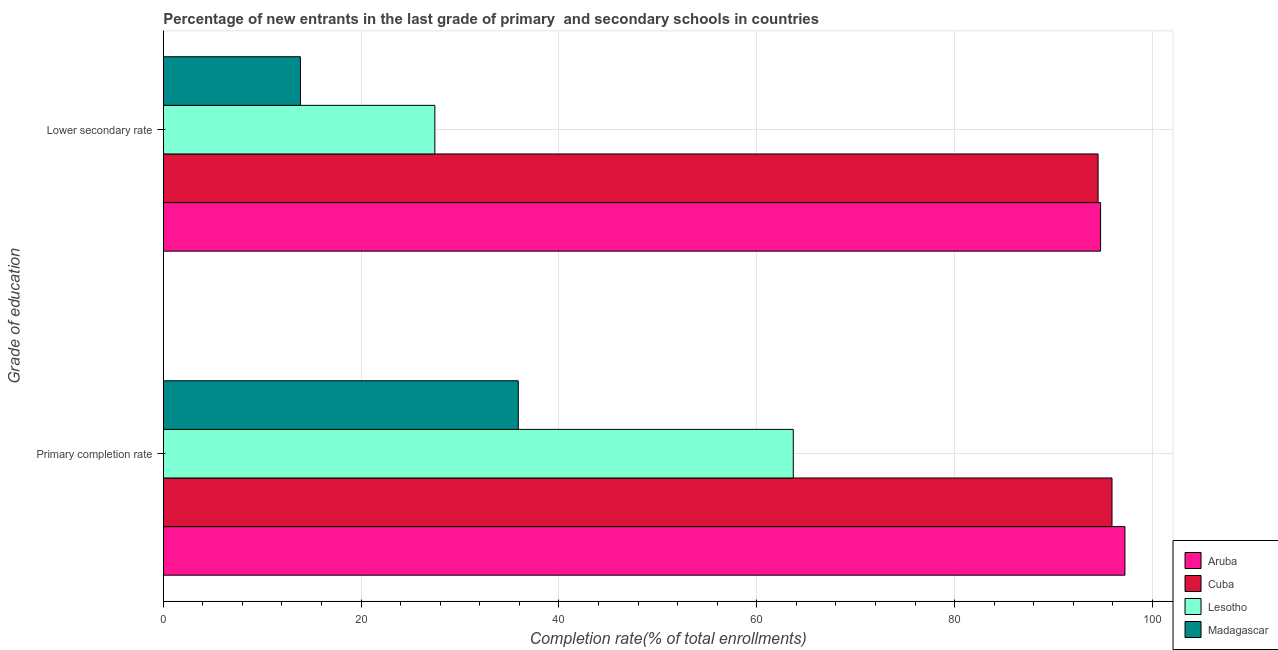How many groups of bars are there?
Offer a very short reply. 2. Are the number of bars per tick equal to the number of legend labels?
Give a very brief answer. Yes. Are the number of bars on each tick of the Y-axis equal?
Your response must be concise. Yes. What is the label of the 1st group of bars from the top?
Provide a short and direct response. Lower secondary rate. What is the completion rate in secondary schools in Lesotho?
Your response must be concise. 27.46. Across all countries, what is the maximum completion rate in secondary schools?
Offer a very short reply. 94.75. Across all countries, what is the minimum completion rate in primary schools?
Offer a very short reply. 35.89. In which country was the completion rate in primary schools maximum?
Your answer should be very brief. Aruba. In which country was the completion rate in secondary schools minimum?
Ensure brevity in your answer.  Madagascar. What is the total completion rate in secondary schools in the graph?
Offer a very short reply. 230.57. What is the difference between the completion rate in primary schools in Cuba and that in Aruba?
Ensure brevity in your answer.  -1.31. What is the difference between the completion rate in primary schools in Lesotho and the completion rate in secondary schools in Cuba?
Your answer should be very brief. -30.81. What is the average completion rate in primary schools per country?
Your answer should be very brief. 73.17. What is the difference between the completion rate in primary schools and completion rate in secondary schools in Aruba?
Your response must be concise. 2.46. In how many countries, is the completion rate in secondary schools greater than 48 %?
Keep it short and to the point. 2. What is the ratio of the completion rate in primary schools in Aruba to that in Lesotho?
Your response must be concise. 1.53. What does the 3rd bar from the top in Lower secondary rate represents?
Offer a terse response. Cuba. What does the 4th bar from the bottom in Lower secondary rate represents?
Provide a short and direct response. Madagascar. What is the difference between two consecutive major ticks on the X-axis?
Keep it short and to the point. 20. Are the values on the major ticks of X-axis written in scientific E-notation?
Your response must be concise. No. Does the graph contain any zero values?
Ensure brevity in your answer.  No. What is the title of the graph?
Make the answer very short. Percentage of new entrants in the last grade of primary  and secondary schools in countries. What is the label or title of the X-axis?
Make the answer very short. Completion rate(% of total enrollments). What is the label or title of the Y-axis?
Make the answer very short. Grade of education. What is the Completion rate(% of total enrollments) in Aruba in Primary completion rate?
Your answer should be very brief. 97.22. What is the Completion rate(% of total enrollments) in Cuba in Primary completion rate?
Your answer should be very brief. 95.91. What is the Completion rate(% of total enrollments) in Lesotho in Primary completion rate?
Provide a succinct answer. 63.69. What is the Completion rate(% of total enrollments) in Madagascar in Primary completion rate?
Give a very brief answer. 35.89. What is the Completion rate(% of total enrollments) in Aruba in Lower secondary rate?
Make the answer very short. 94.75. What is the Completion rate(% of total enrollments) in Cuba in Lower secondary rate?
Your answer should be compact. 94.5. What is the Completion rate(% of total enrollments) of Lesotho in Lower secondary rate?
Make the answer very short. 27.46. What is the Completion rate(% of total enrollments) of Madagascar in Lower secondary rate?
Your response must be concise. 13.87. Across all Grade of education, what is the maximum Completion rate(% of total enrollments) in Aruba?
Provide a succinct answer. 97.22. Across all Grade of education, what is the maximum Completion rate(% of total enrollments) in Cuba?
Your answer should be very brief. 95.91. Across all Grade of education, what is the maximum Completion rate(% of total enrollments) in Lesotho?
Offer a terse response. 63.69. Across all Grade of education, what is the maximum Completion rate(% of total enrollments) in Madagascar?
Keep it short and to the point. 35.89. Across all Grade of education, what is the minimum Completion rate(% of total enrollments) in Aruba?
Your answer should be very brief. 94.75. Across all Grade of education, what is the minimum Completion rate(% of total enrollments) in Cuba?
Your response must be concise. 94.5. Across all Grade of education, what is the minimum Completion rate(% of total enrollments) of Lesotho?
Your answer should be very brief. 27.46. Across all Grade of education, what is the minimum Completion rate(% of total enrollments) in Madagascar?
Your response must be concise. 13.87. What is the total Completion rate(% of total enrollments) of Aruba in the graph?
Ensure brevity in your answer.  191.97. What is the total Completion rate(% of total enrollments) in Cuba in the graph?
Make the answer very short. 190.41. What is the total Completion rate(% of total enrollments) in Lesotho in the graph?
Offer a terse response. 91.14. What is the total Completion rate(% of total enrollments) in Madagascar in the graph?
Offer a very short reply. 49.75. What is the difference between the Completion rate(% of total enrollments) of Aruba in Primary completion rate and that in Lower secondary rate?
Offer a very short reply. 2.46. What is the difference between the Completion rate(% of total enrollments) of Cuba in Primary completion rate and that in Lower secondary rate?
Your answer should be compact. 1.41. What is the difference between the Completion rate(% of total enrollments) in Lesotho in Primary completion rate and that in Lower secondary rate?
Offer a very short reply. 36.23. What is the difference between the Completion rate(% of total enrollments) of Madagascar in Primary completion rate and that in Lower secondary rate?
Your answer should be very brief. 22.02. What is the difference between the Completion rate(% of total enrollments) in Aruba in Primary completion rate and the Completion rate(% of total enrollments) in Cuba in Lower secondary rate?
Your answer should be very brief. 2.72. What is the difference between the Completion rate(% of total enrollments) in Aruba in Primary completion rate and the Completion rate(% of total enrollments) in Lesotho in Lower secondary rate?
Make the answer very short. 69.76. What is the difference between the Completion rate(% of total enrollments) in Aruba in Primary completion rate and the Completion rate(% of total enrollments) in Madagascar in Lower secondary rate?
Offer a terse response. 83.35. What is the difference between the Completion rate(% of total enrollments) in Cuba in Primary completion rate and the Completion rate(% of total enrollments) in Lesotho in Lower secondary rate?
Offer a terse response. 68.45. What is the difference between the Completion rate(% of total enrollments) in Cuba in Primary completion rate and the Completion rate(% of total enrollments) in Madagascar in Lower secondary rate?
Provide a short and direct response. 82.04. What is the difference between the Completion rate(% of total enrollments) in Lesotho in Primary completion rate and the Completion rate(% of total enrollments) in Madagascar in Lower secondary rate?
Make the answer very short. 49.82. What is the average Completion rate(% of total enrollments) of Aruba per Grade of education?
Offer a terse response. 95.98. What is the average Completion rate(% of total enrollments) in Cuba per Grade of education?
Give a very brief answer. 95.2. What is the average Completion rate(% of total enrollments) in Lesotho per Grade of education?
Your answer should be compact. 45.57. What is the average Completion rate(% of total enrollments) in Madagascar per Grade of education?
Keep it short and to the point. 24.88. What is the difference between the Completion rate(% of total enrollments) in Aruba and Completion rate(% of total enrollments) in Cuba in Primary completion rate?
Keep it short and to the point. 1.31. What is the difference between the Completion rate(% of total enrollments) of Aruba and Completion rate(% of total enrollments) of Lesotho in Primary completion rate?
Give a very brief answer. 33.53. What is the difference between the Completion rate(% of total enrollments) of Aruba and Completion rate(% of total enrollments) of Madagascar in Primary completion rate?
Offer a terse response. 61.33. What is the difference between the Completion rate(% of total enrollments) in Cuba and Completion rate(% of total enrollments) in Lesotho in Primary completion rate?
Give a very brief answer. 32.22. What is the difference between the Completion rate(% of total enrollments) of Cuba and Completion rate(% of total enrollments) of Madagascar in Primary completion rate?
Give a very brief answer. 60.02. What is the difference between the Completion rate(% of total enrollments) of Lesotho and Completion rate(% of total enrollments) of Madagascar in Primary completion rate?
Your answer should be compact. 27.8. What is the difference between the Completion rate(% of total enrollments) of Aruba and Completion rate(% of total enrollments) of Cuba in Lower secondary rate?
Provide a short and direct response. 0.25. What is the difference between the Completion rate(% of total enrollments) of Aruba and Completion rate(% of total enrollments) of Lesotho in Lower secondary rate?
Provide a short and direct response. 67.3. What is the difference between the Completion rate(% of total enrollments) of Aruba and Completion rate(% of total enrollments) of Madagascar in Lower secondary rate?
Provide a succinct answer. 80.89. What is the difference between the Completion rate(% of total enrollments) of Cuba and Completion rate(% of total enrollments) of Lesotho in Lower secondary rate?
Give a very brief answer. 67.05. What is the difference between the Completion rate(% of total enrollments) in Cuba and Completion rate(% of total enrollments) in Madagascar in Lower secondary rate?
Make the answer very short. 80.64. What is the difference between the Completion rate(% of total enrollments) of Lesotho and Completion rate(% of total enrollments) of Madagascar in Lower secondary rate?
Ensure brevity in your answer.  13.59. What is the ratio of the Completion rate(% of total enrollments) in Aruba in Primary completion rate to that in Lower secondary rate?
Offer a very short reply. 1.03. What is the ratio of the Completion rate(% of total enrollments) in Cuba in Primary completion rate to that in Lower secondary rate?
Offer a terse response. 1.01. What is the ratio of the Completion rate(% of total enrollments) of Lesotho in Primary completion rate to that in Lower secondary rate?
Offer a terse response. 2.32. What is the ratio of the Completion rate(% of total enrollments) of Madagascar in Primary completion rate to that in Lower secondary rate?
Ensure brevity in your answer.  2.59. What is the difference between the highest and the second highest Completion rate(% of total enrollments) in Aruba?
Make the answer very short. 2.46. What is the difference between the highest and the second highest Completion rate(% of total enrollments) of Cuba?
Your answer should be very brief. 1.41. What is the difference between the highest and the second highest Completion rate(% of total enrollments) of Lesotho?
Your answer should be compact. 36.23. What is the difference between the highest and the second highest Completion rate(% of total enrollments) of Madagascar?
Offer a very short reply. 22.02. What is the difference between the highest and the lowest Completion rate(% of total enrollments) of Aruba?
Provide a succinct answer. 2.46. What is the difference between the highest and the lowest Completion rate(% of total enrollments) in Cuba?
Your answer should be compact. 1.41. What is the difference between the highest and the lowest Completion rate(% of total enrollments) of Lesotho?
Offer a terse response. 36.23. What is the difference between the highest and the lowest Completion rate(% of total enrollments) in Madagascar?
Provide a short and direct response. 22.02. 